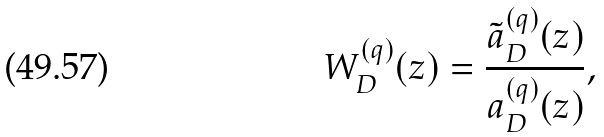Convert formula to latex. <formula><loc_0><loc_0><loc_500><loc_500>W _ { D } ^ { ( q ) } ( z ) = \frac { \tilde { a } _ { D } ^ { ( q ) } ( z ) } { a _ { D } ^ { ( q ) } ( z ) } ,</formula> 